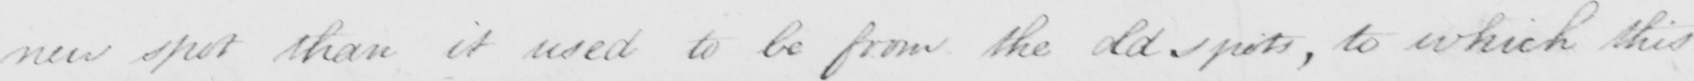What text is written in this handwritten line? new spot than it used to be from the old spots, to which this 